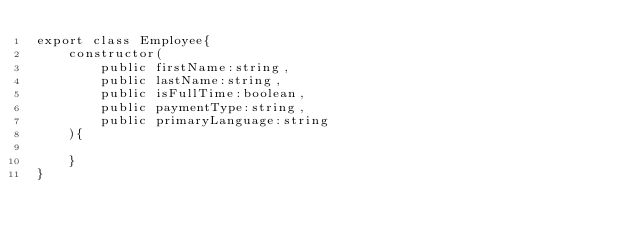<code> <loc_0><loc_0><loc_500><loc_500><_TypeScript_>export class Employee{
    constructor(
        public firstName:string,
        public lastName:string,
        public isFullTime:boolean,
        public paymentType:string,
        public primaryLanguage:string
    ){

    }
}</code> 